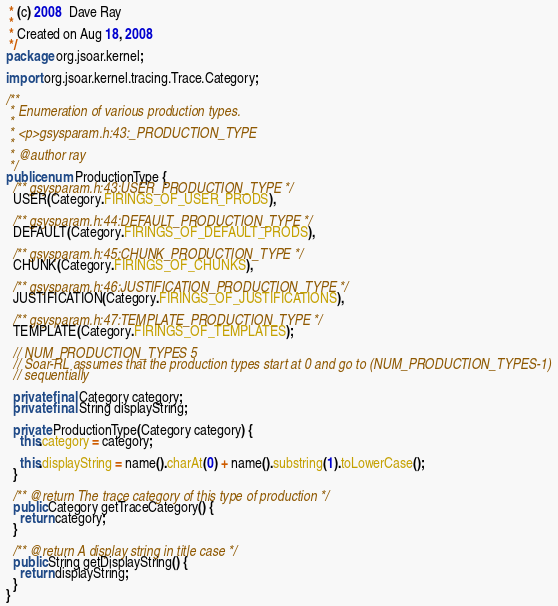<code> <loc_0><loc_0><loc_500><loc_500><_Java_> * (c) 2008  Dave Ray
 *
 * Created on Aug 18, 2008
 */
package org.jsoar.kernel;

import org.jsoar.kernel.tracing.Trace.Category;

/**
 * Enumeration of various production types.
 *
 * <p>gsysparam.h:43:_PRODUCTION_TYPE
 *
 * @author ray
 */
public enum ProductionType {
  /** gsysparam.h:43:USER_PRODUCTION_TYPE */
  USER(Category.FIRINGS_OF_USER_PRODS),

  /** gsysparam.h:44:DEFAULT_PRODUCTION_TYPE */
  DEFAULT(Category.FIRINGS_OF_DEFAULT_PRODS),

  /** gsysparam.h:45:CHUNK_PRODUCTION_TYPE */
  CHUNK(Category.FIRINGS_OF_CHUNKS),

  /** gsysparam.h:46:JUSTIFICATION_PRODUCTION_TYPE */
  JUSTIFICATION(Category.FIRINGS_OF_JUSTIFICATIONS),

  /** gsysparam.h:47:TEMPLATE_PRODUCTION_TYPE */
  TEMPLATE(Category.FIRINGS_OF_TEMPLATES);

  // NUM_PRODUCTION_TYPES 5
  // Soar-RL assumes that the production types start at 0 and go to (NUM_PRODUCTION_TYPES-1)
  // sequentially

  private final Category category;
  private final String displayString;

  private ProductionType(Category category) {
    this.category = category;

    this.displayString = name().charAt(0) + name().substring(1).toLowerCase();
  }

  /** @return The trace category of this type of production */
  public Category getTraceCategory() {
    return category;
  }

  /** @return A display string in title case */
  public String getDisplayString() {
    return displayString;
  }
}
</code> 